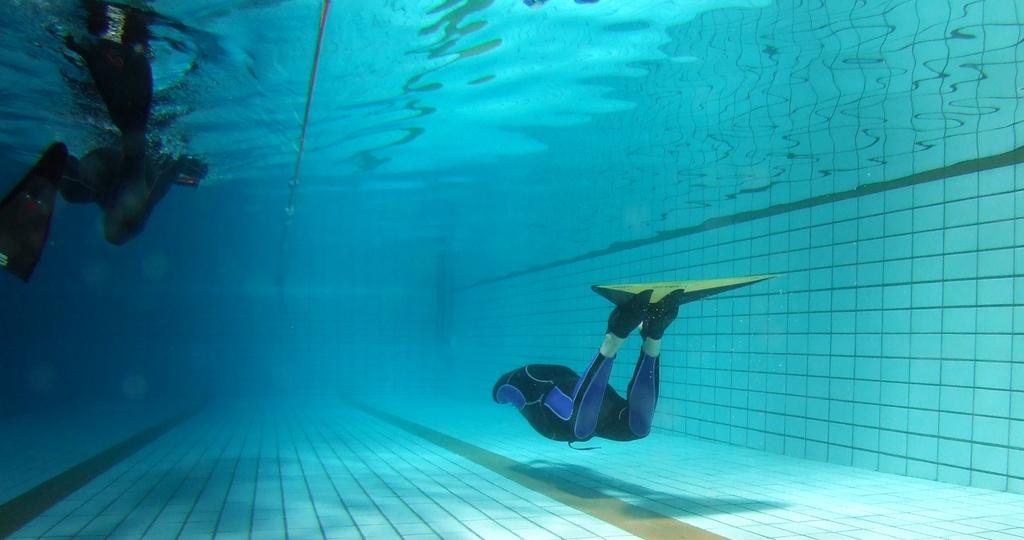What are the two people in the image doing? The two people in the image are swimming in the pool. Can you describe any objects in the image besides the people? Yes, there is a rope in the image. What is the material of the wall on the right side of the image? The wall on the right side of the image is made of tiles. What type of glove is being used to measure the depth of the pool in the image? There is no glove or measuring activity present in the image; it features two people swimming and a rope. 